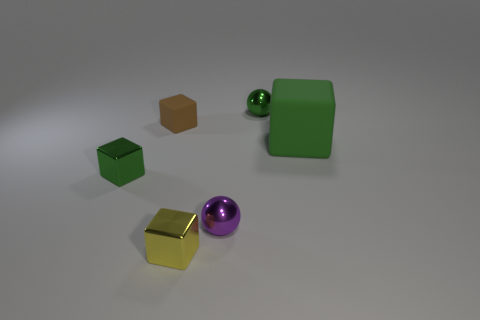Are there any other things that have the same size as the green matte thing?
Give a very brief answer. No. Do the large green matte object and the small green metal object behind the large matte cube have the same shape?
Your response must be concise. No. What number of yellow metal objects have the same size as the brown rubber cube?
Your answer should be very brief. 1. There is a small object in front of the tiny purple metallic ball; does it have the same shape as the green metallic object right of the purple shiny sphere?
Offer a terse response. No. The small ball behind the metallic cube that is behind the small yellow thing is what color?
Offer a terse response. Green. There is a small matte thing that is the same shape as the yellow shiny object; what color is it?
Ensure brevity in your answer.  Brown. What is the size of the green rubber thing that is the same shape as the yellow shiny object?
Ensure brevity in your answer.  Large. There is a tiny yellow thing that is left of the purple metal sphere; what is it made of?
Your answer should be very brief. Metal. Is the number of small matte objects that are in front of the brown object less than the number of purple things?
Give a very brief answer. Yes. What shape is the tiny green shiny object left of the metallic ball that is in front of the green metal ball?
Provide a short and direct response. Cube. 